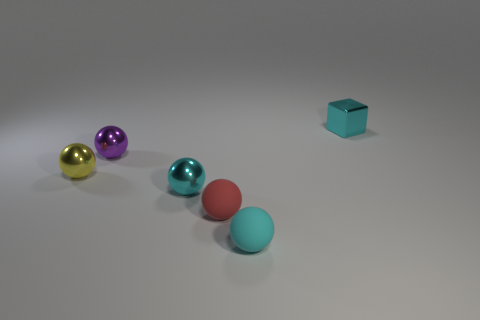There is a red thing in front of the tiny yellow thing; is it the same size as the cyan metal object to the left of the small cyan metal cube?
Provide a short and direct response. Yes. What number of objects are either tiny cyan objects or small matte balls?
Make the answer very short. 4. What is the material of the tiny cyan thing that is in front of the matte object on the left side of the small cyan rubber object?
Your answer should be very brief. Rubber. What number of cyan objects are the same shape as the red object?
Ensure brevity in your answer.  2. Are there any metal spheres that have the same color as the tiny cube?
Your response must be concise. Yes. How many objects are cyan metallic objects in front of the block or metal things that are in front of the cyan shiny block?
Make the answer very short. 3. Is there a thing behind the rubber object that is to the right of the red ball?
Provide a succinct answer. Yes. What shape is the red rubber thing that is the same size as the purple shiny ball?
Give a very brief answer. Sphere. What number of things are small metal things that are to the left of the tiny cyan matte sphere or tiny red things?
Give a very brief answer. 4. How many other objects are there of the same material as the red sphere?
Your response must be concise. 1. 